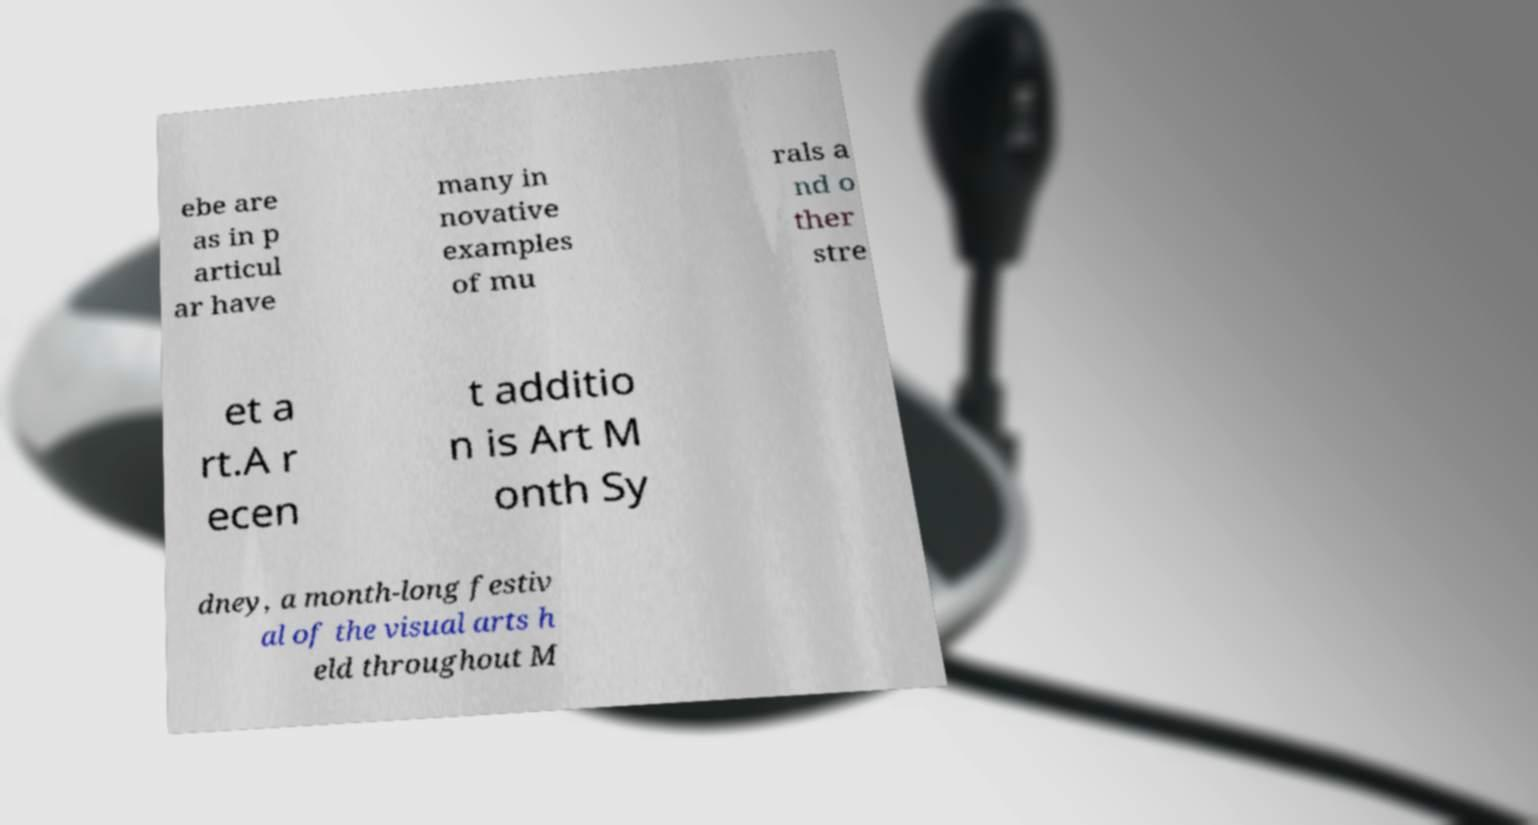Can you read and provide the text displayed in the image?This photo seems to have some interesting text. Can you extract and type it out for me? ebe are as in p articul ar have many in novative examples of mu rals a nd o ther stre et a rt.A r ecen t additio n is Art M onth Sy dney, a month-long festiv al of the visual arts h eld throughout M 